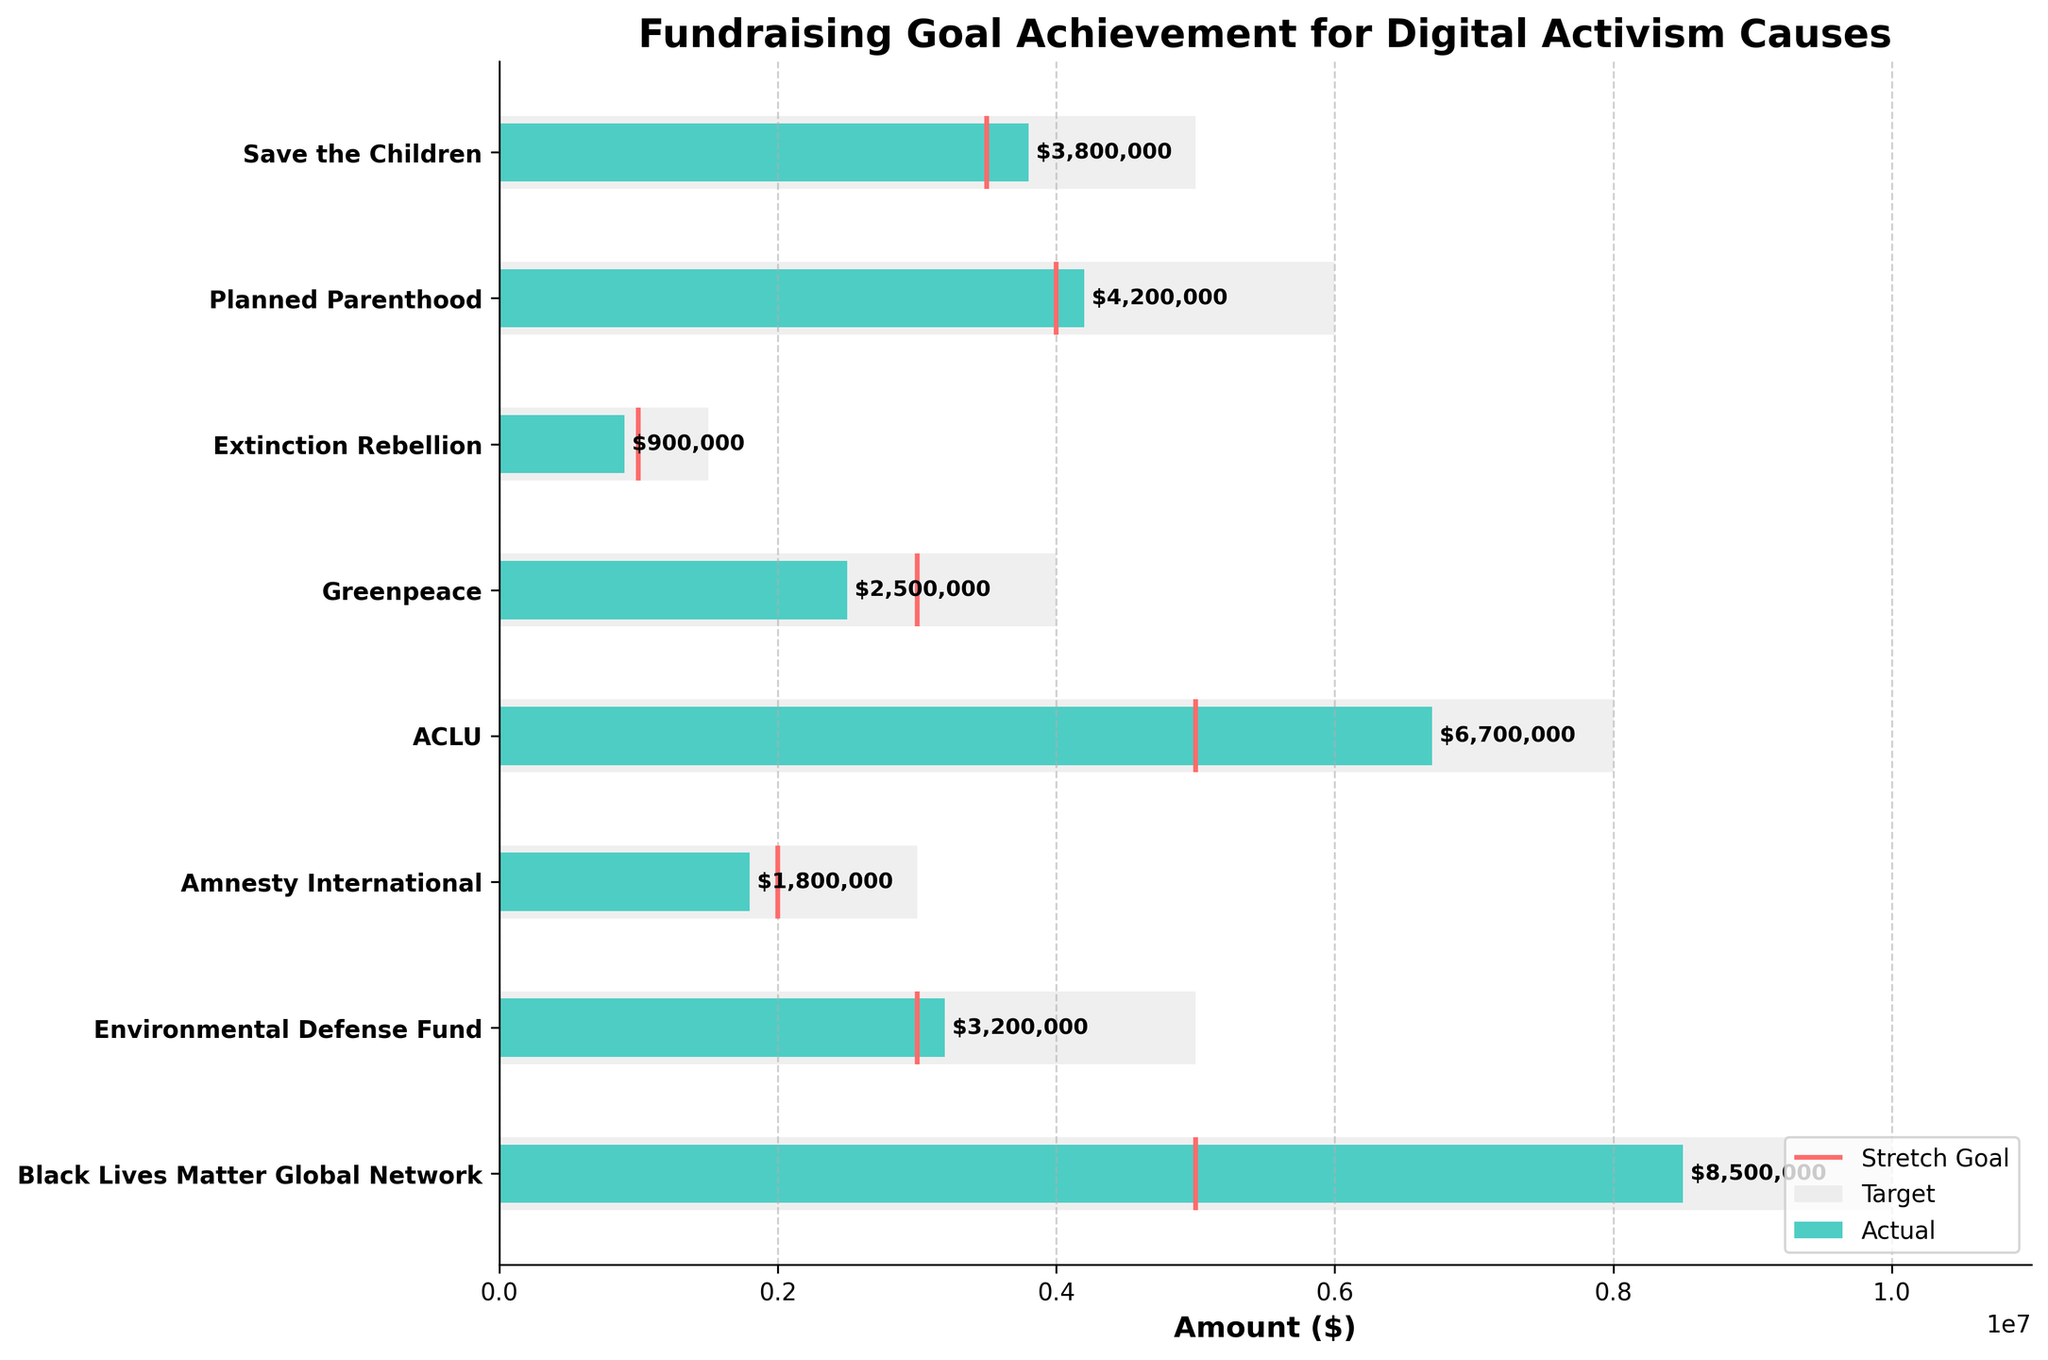What is the title of the figure? The title of the figure is located at the top and provides a clear description of what the chart is about.
Answer: Fundraising Goal Achievement for Digital Activism Causes What does the color gray represent in the chart? Observing the legend in the chart, the gray color represents the stretch goals for each cause.
Answer: Stretch Goal Which cause has the highest actual fundraising amount? The highest actual fundraising amount can be found by looking for the longest turquoise bar among the causes.
Answer: Black Lives Matter Global Network Which cause did not meet its target fundraising goal? Identify the causes where the turquoise actual value bar is shorter than the red target line.
Answer: Greenpeace How many causes met or exceeded their stretch goal? Count the number of causes for which the turquoise actual value bar is equal to or greater than the length of the gray stretch goal bar.
Answer: 1 (Black Lives Matter Global Network) What is the difference between the actual and target amount for ACLU? Subtract the target amount from the actual amount for the ACLU cause.
Answer: $1,700,000 Which causes have actual amounts greater than their stretch goals? Compare the lengths of the turquoise actual value bars to their corresponding gray stretch goal bars and list the causes with longer actual value bars.
Answer: None How much more did Planned Parenthood raise compared to Amnesty International? Subtract the actual amount for Amnesty International from the actual amount for Planned Parenthood.
Answer: $2,400,000 What is the average actual fundraising amount for all the causes? Sum the actual amounts for all causes and divide by the number of causes. Calculation: ($8,500,000 + $3,200,000 + $1,800,000 + $6,700,000 + $2,500,000 + $900,000 + $4,200,000 + $3,800,000) / 8
Answer: $3,825,000 What percentage of its stretch goal did Extinction Rebellion achieve? Divide Extinction Rebellion's actual amount by its stretch goal and multiply by 100 to get the percentage. Calculation: ($900,000 / $1,500,000) * 100
Answer: 60% 